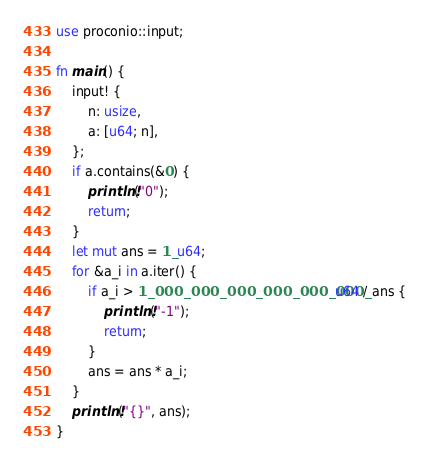Convert code to text. <code><loc_0><loc_0><loc_500><loc_500><_Rust_>use proconio::input;

fn main() {
    input! {
        n: usize,
        a: [u64; n],
    };
    if a.contains(&0) {
        println!("0");
        return;
    }
    let mut ans = 1_u64;
    for &a_i in a.iter() {
        if a_i > 1_000_000_000_000_000_000_u64 / ans {
            println!("-1");
            return;
        }
        ans = ans * a_i;
    }
    println!("{}", ans);
}
</code> 